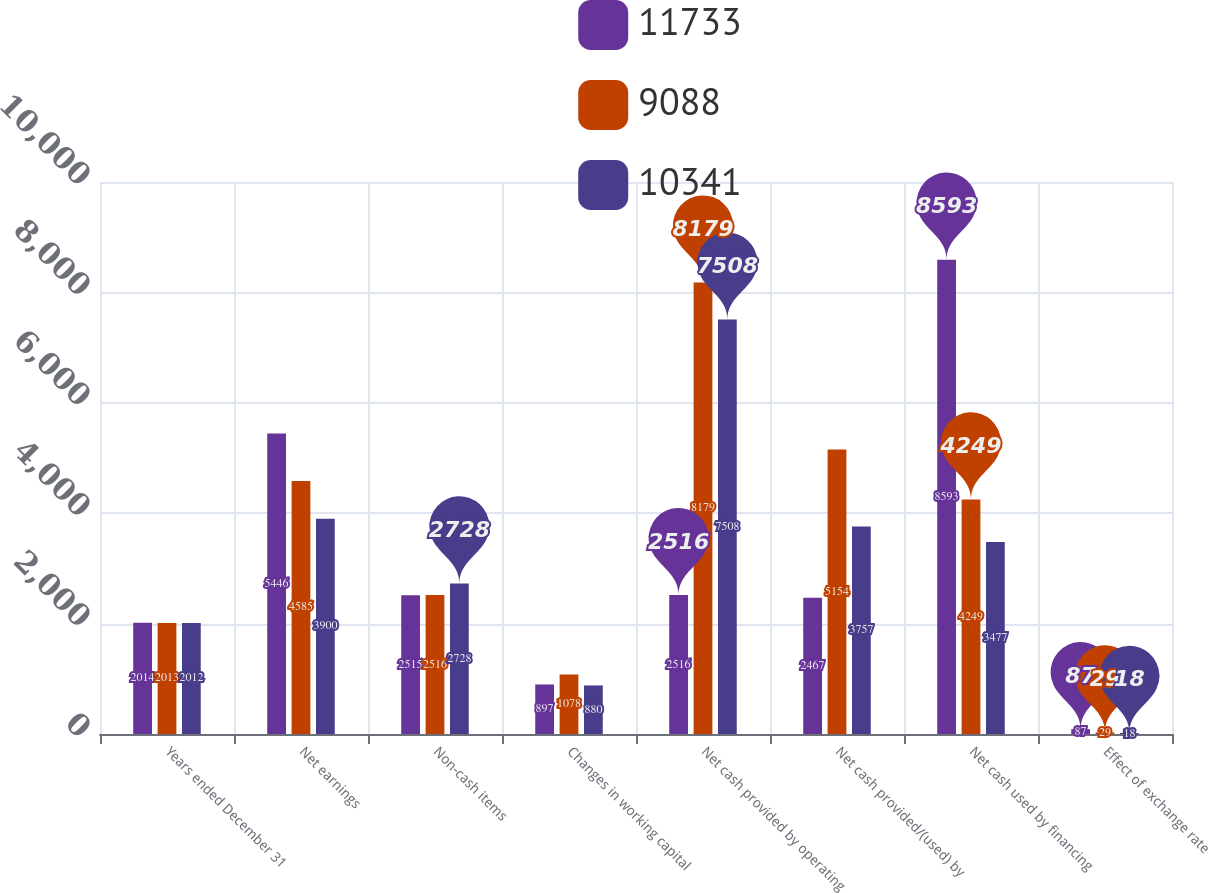Convert chart. <chart><loc_0><loc_0><loc_500><loc_500><stacked_bar_chart><ecel><fcel>Years ended December 31<fcel>Net earnings<fcel>Non-cash items<fcel>Changes in working capital<fcel>Net cash provided by operating<fcel>Net cash provided/(used) by<fcel>Net cash used by financing<fcel>Effect of exchange rate<nl><fcel>11733<fcel>2014<fcel>5446<fcel>2515<fcel>897<fcel>2516<fcel>2467<fcel>8593<fcel>87<nl><fcel>9088<fcel>2013<fcel>4585<fcel>2516<fcel>1078<fcel>8179<fcel>5154<fcel>4249<fcel>29<nl><fcel>10341<fcel>2012<fcel>3900<fcel>2728<fcel>880<fcel>7508<fcel>3757<fcel>3477<fcel>18<nl></chart> 